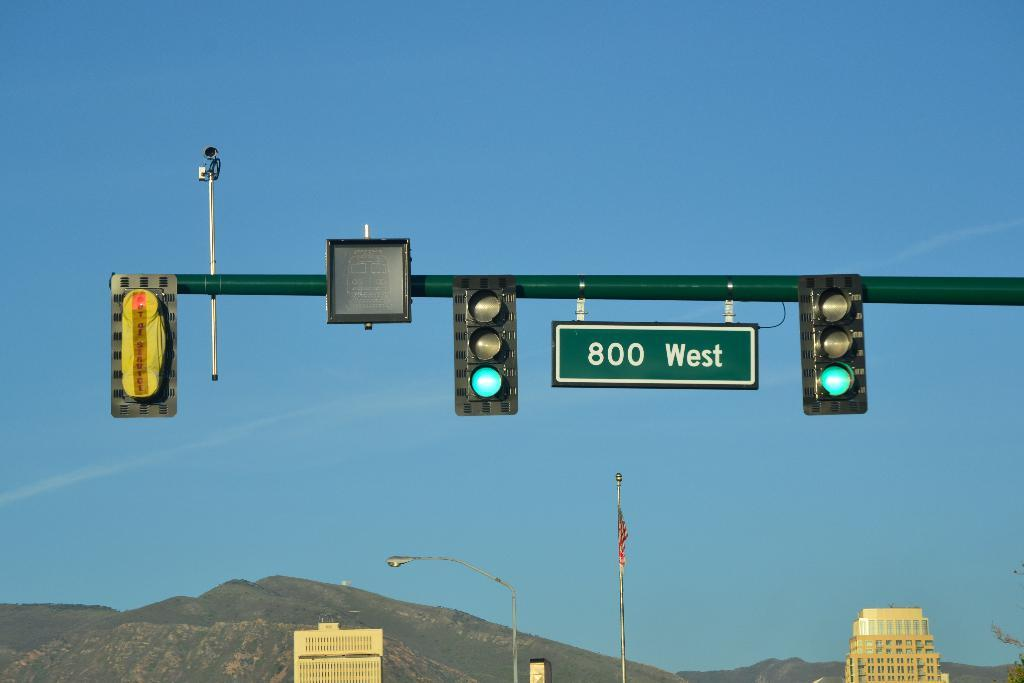<image>
Offer a succinct explanation of the picture presented. A green sign reading 800 West hangs between two traffic lights which are green for go. 